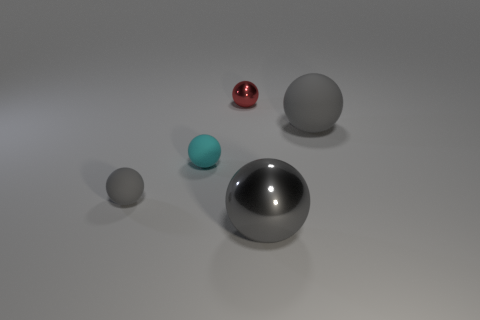How many gray spheres must be subtracted to get 1 gray spheres? 2 Subtract all red metallic spheres. How many spheres are left? 4 Subtract all cyan balls. How many balls are left? 4 Subtract 1 balls. How many balls are left? 4 Add 4 gray objects. How many gray objects are left? 7 Add 2 blue cylinders. How many blue cylinders exist? 2 Add 3 large brown metallic balls. How many objects exist? 8 Subtract 0 blue cylinders. How many objects are left? 5 Subtract all yellow spheres. Subtract all blue cylinders. How many spheres are left? 5 Subtract all gray blocks. How many gray balls are left? 3 